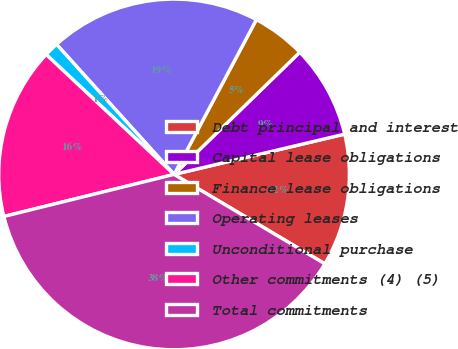<chart> <loc_0><loc_0><loc_500><loc_500><pie_chart><fcel>Debt principal and interest<fcel>Capital lease obligations<fcel>Finance lease obligations<fcel>Operating leases<fcel>Unconditional purchase<fcel>Other commitments (4) (5)<fcel>Total commitments<nl><fcel>12.21%<fcel>8.58%<fcel>4.95%<fcel>19.47%<fcel>1.32%<fcel>15.84%<fcel>37.63%<nl></chart> 